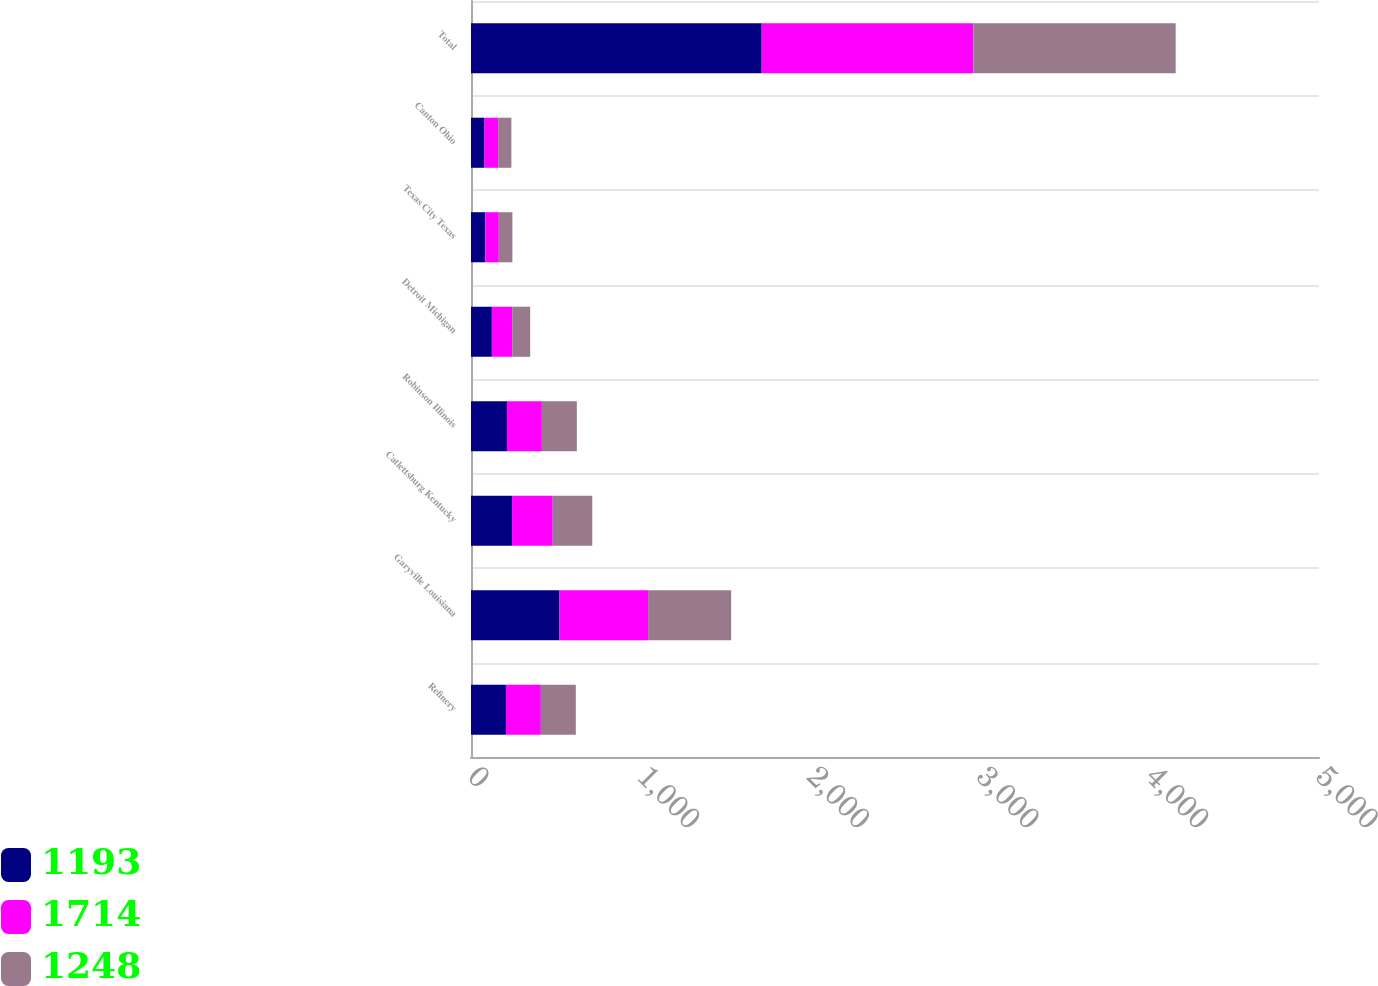<chart> <loc_0><loc_0><loc_500><loc_500><stacked_bar_chart><ecel><fcel>Refinery<fcel>Garyville Louisiana<fcel>Catlettsburg Kentucky<fcel>Robinson Illinois<fcel>Detroit Michigan<fcel>Texas City Texas<fcel>Canton Ohio<fcel>Total<nl><fcel>1193<fcel>206<fcel>522<fcel>242<fcel>212<fcel>123<fcel>84<fcel>80<fcel>1714<nl><fcel>1714<fcel>206<fcel>522<fcel>240<fcel>206<fcel>120<fcel>80<fcel>80<fcel>1248<nl><fcel>1248<fcel>206<fcel>490<fcel>233<fcel>206<fcel>106<fcel>80<fcel>78<fcel>1193<nl></chart> 